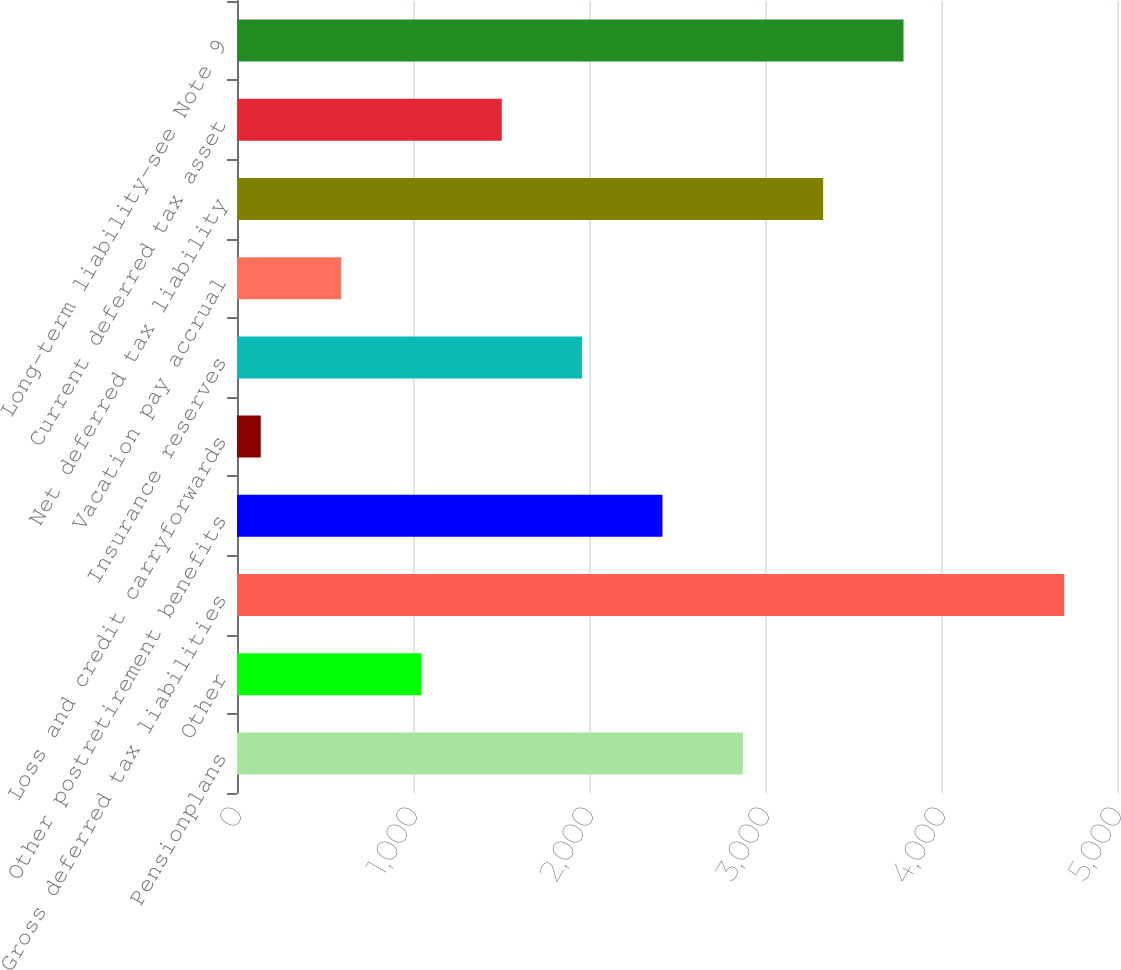Convert chart to OTSL. <chart><loc_0><loc_0><loc_500><loc_500><bar_chart><fcel>Pensionplans<fcel>Other<fcel>Gross deferred tax liabilities<fcel>Other postretirement benefits<fcel>Loss and credit carryforwards<fcel>Insurance reserves<fcel>Vacation pay accrual<fcel>Net deferred tax liability<fcel>Current deferred tax asset<fcel>Long-term liability-see Note 9<nl><fcel>2874<fcel>1048<fcel>4700<fcel>2417.5<fcel>135<fcel>1961<fcel>591.5<fcel>3330.5<fcel>1504.5<fcel>3787<nl></chart> 